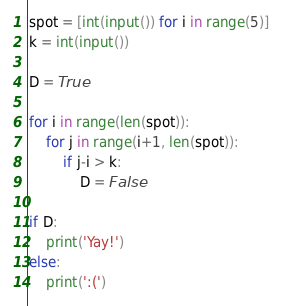Convert code to text. <code><loc_0><loc_0><loc_500><loc_500><_Python_>spot = [int(input()) for i in range(5)]
k = int(input())

D = True

for i in range(len(spot)):
    for j in range(i+1, len(spot)):
        if j-i > k:
            D = False

if D:
    print('Yay!')
else:
    print(':(')</code> 